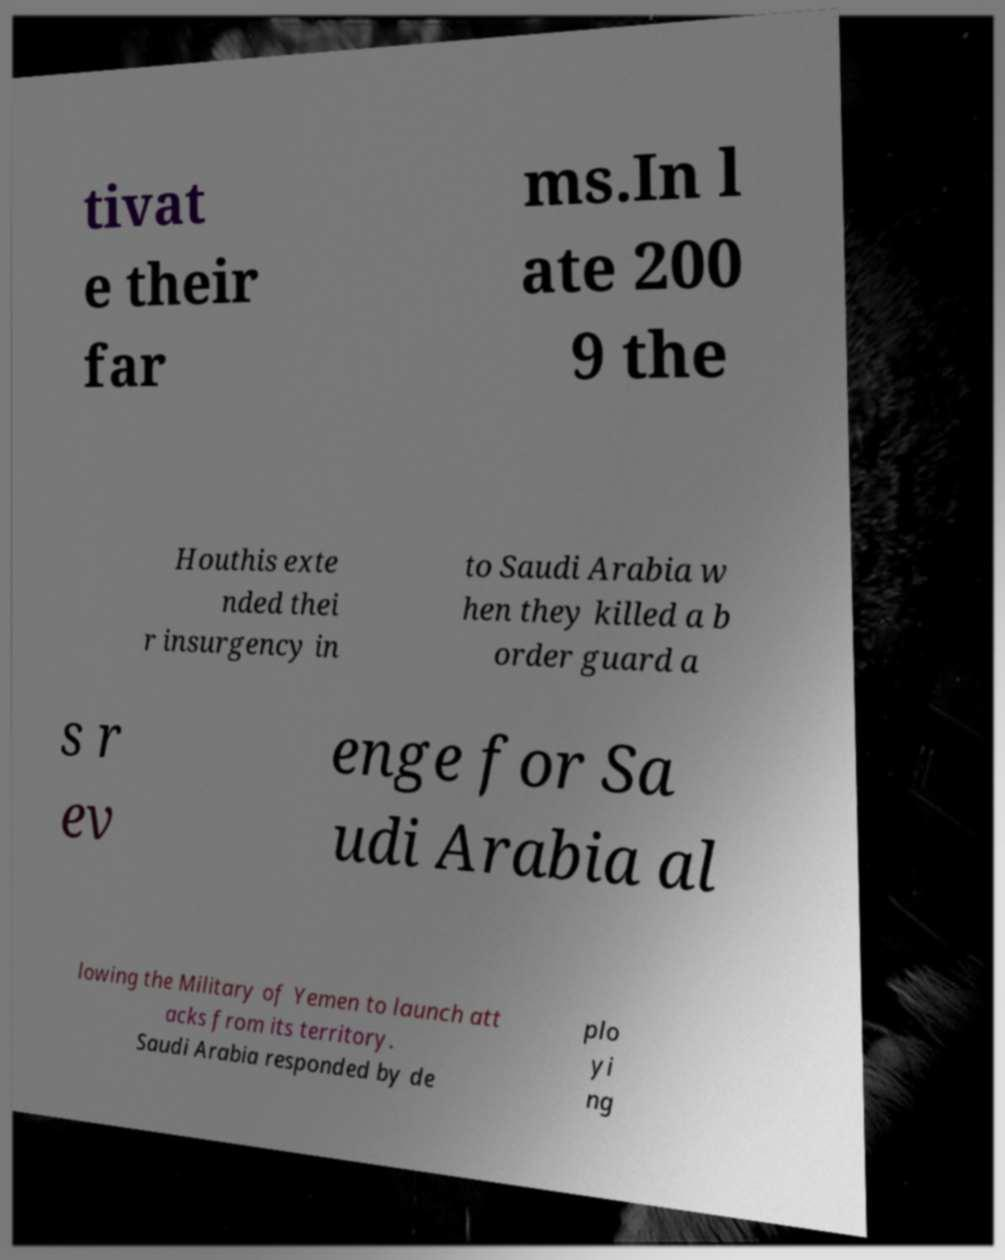Please identify and transcribe the text found in this image. tivat e their far ms.In l ate 200 9 the Houthis exte nded thei r insurgency in to Saudi Arabia w hen they killed a b order guard a s r ev enge for Sa udi Arabia al lowing the Military of Yemen to launch att acks from its territory. Saudi Arabia responded by de plo yi ng 